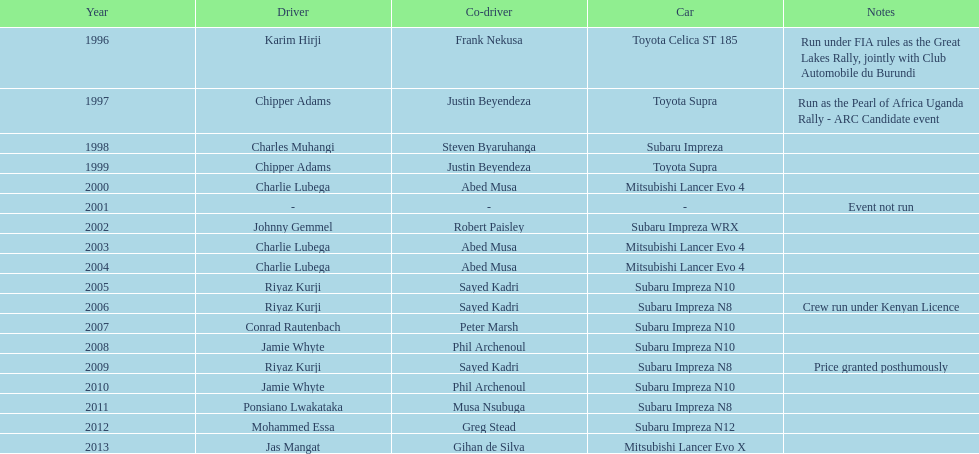What is the number of instances when charlie lubega served as a driver? 3. 